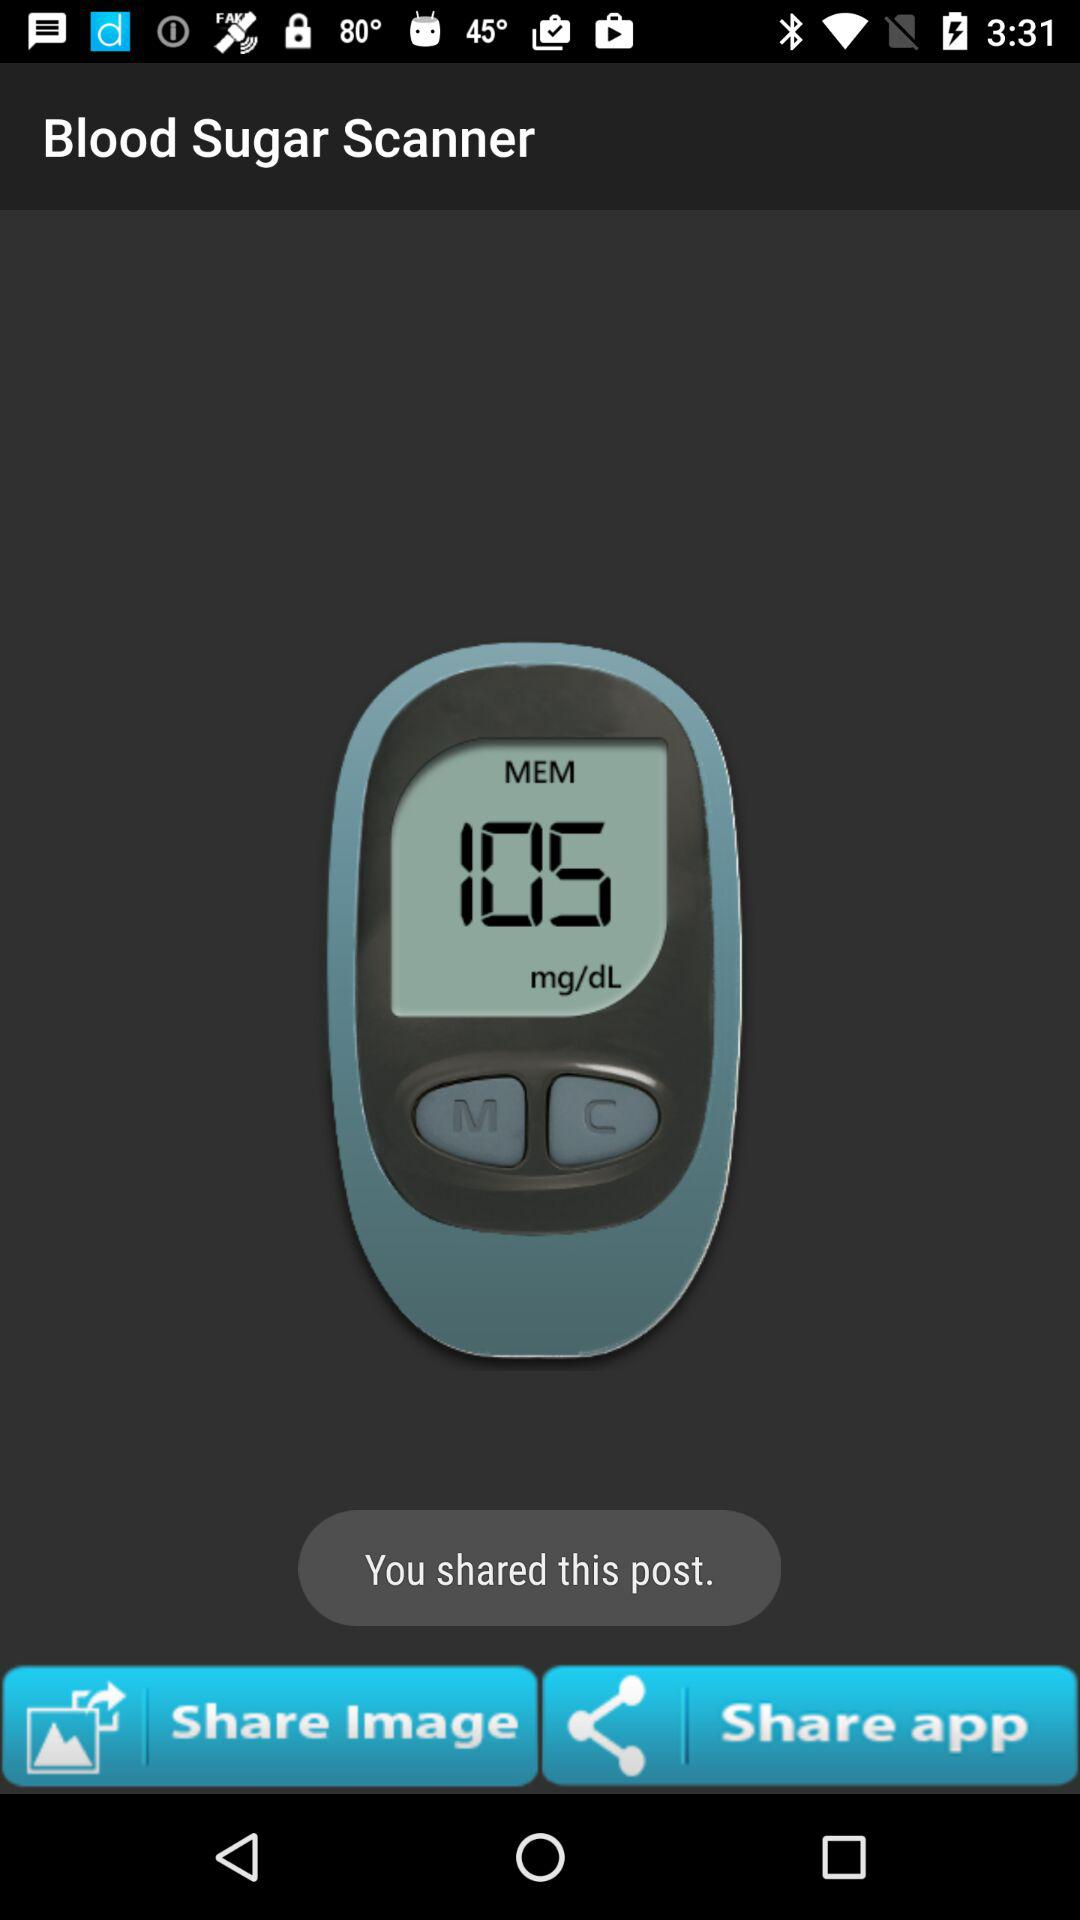What is the blood sugar level? The blood sugar level is 105 mg/dl. 